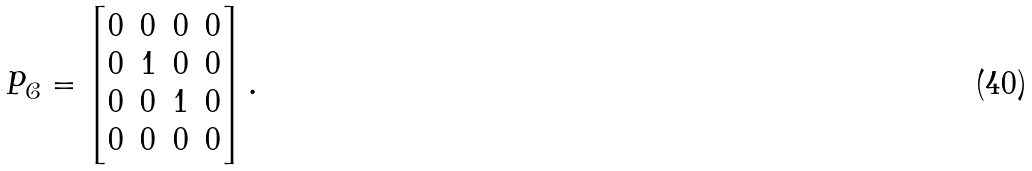<formula> <loc_0><loc_0><loc_500><loc_500>P _ { \mathcal { C } } = \begin{bmatrix} 0 & 0 & 0 & 0 \\ 0 & 1 & 0 & 0 \\ 0 & 0 & 1 & 0 \\ 0 & 0 & 0 & 0 \end{bmatrix} .</formula> 